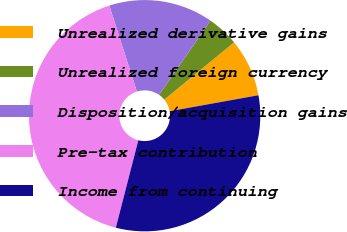Convert chart. <chart><loc_0><loc_0><loc_500><loc_500><pie_chart><fcel>Unrealized derivative gains<fcel>Unrealized foreign currency<fcel>Disposition/acquisition gains<fcel>Pre-tax contribution<fcel>Income from continuing<nl><fcel>8.1%<fcel>4.44%<fcel>14.57%<fcel>41.05%<fcel>31.84%<nl></chart> 